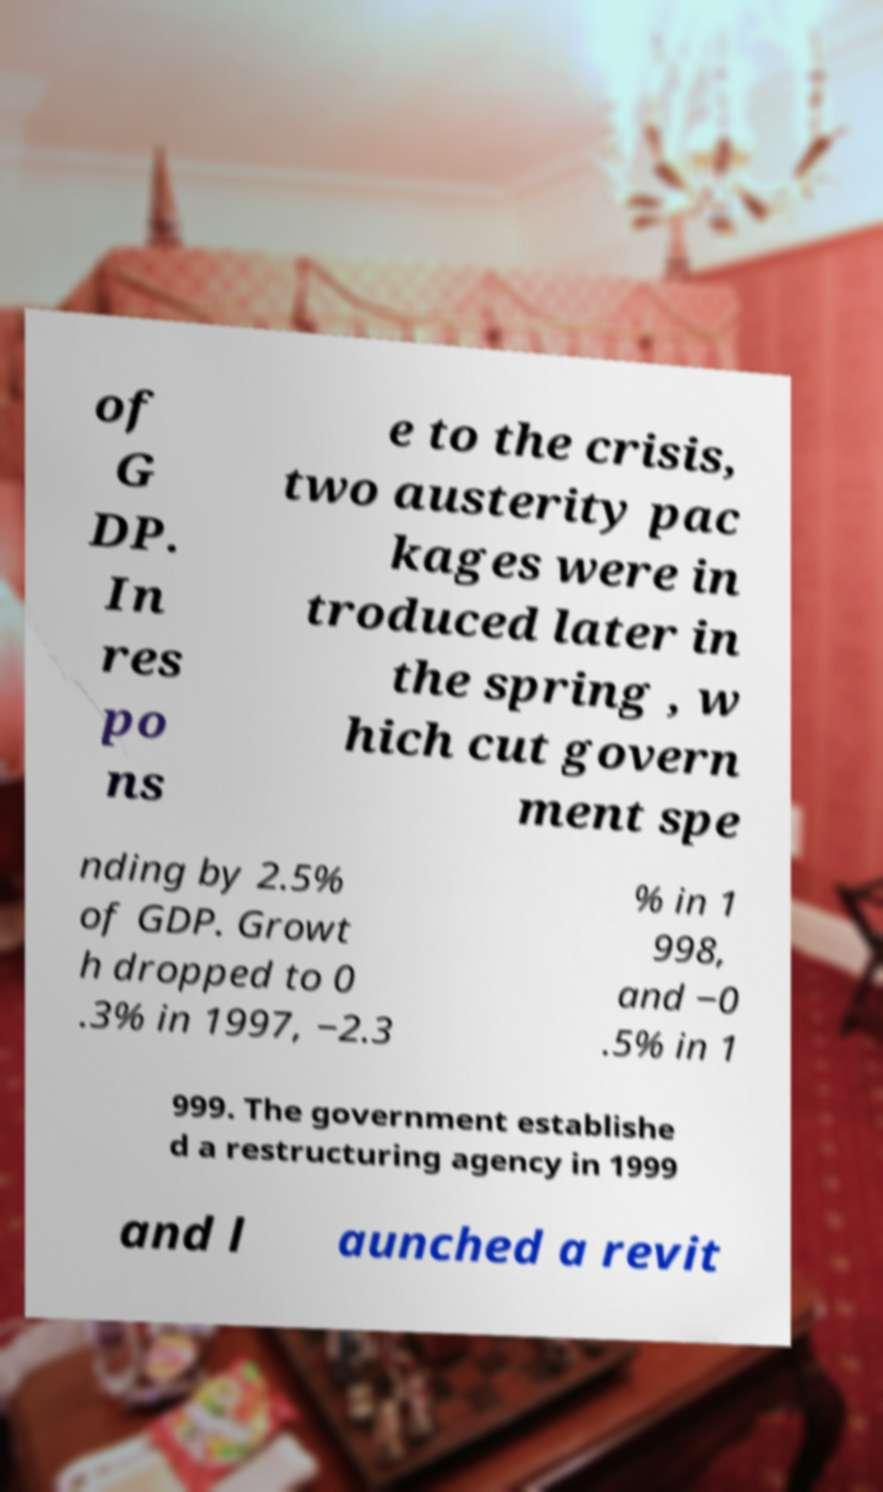Can you read and provide the text displayed in the image?This photo seems to have some interesting text. Can you extract and type it out for me? of G DP. In res po ns e to the crisis, two austerity pac kages were in troduced later in the spring , w hich cut govern ment spe nding by 2.5% of GDP. Growt h dropped to 0 .3% in 1997, −2.3 % in 1 998, and −0 .5% in 1 999. The government establishe d a restructuring agency in 1999 and l aunched a revit 